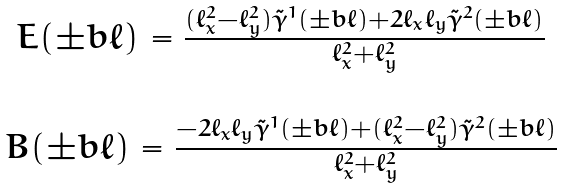<formula> <loc_0><loc_0><loc_500><loc_500>\begin{matrix} E ( \pm b { \ell } ) = \frac { ( \ell _ { x } ^ { 2 } - \ell _ { y } ^ { 2 } ) \tilde { \gamma } ^ { 1 } ( \pm b { \ell } ) + 2 \ell _ { x } \ell _ { y } \tilde { \gamma } ^ { 2 } ( \pm b { \ell } ) } { \ell _ { x } ^ { 2 } + \ell _ { y } ^ { 2 } } \\ \\ B ( \pm b { \ell } ) = \frac { - 2 \ell _ { x } \ell _ { y } \tilde { \gamma } ^ { 1 } ( \pm b { \ell } ) + ( \ell _ { x } ^ { 2 } - \ell _ { y } ^ { 2 } ) \tilde { \gamma } ^ { 2 } ( \pm b { \ell } ) } { \ell _ { x } ^ { 2 } + \ell _ { y } ^ { 2 } } \end{matrix}</formula> 